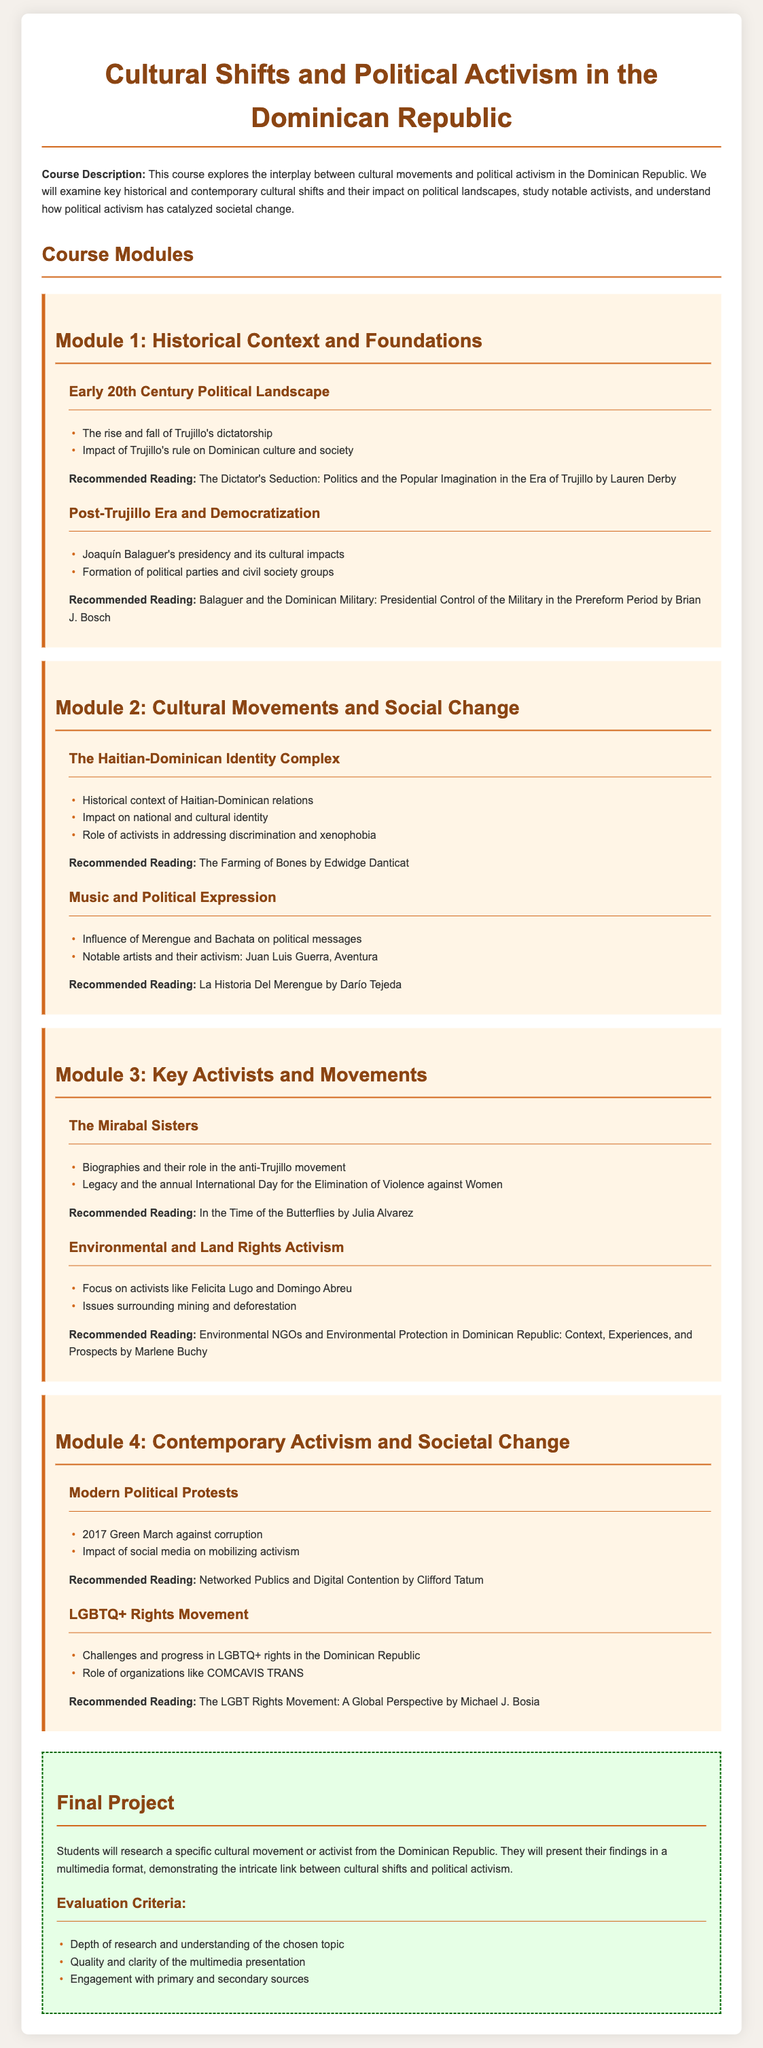What is the title of the course? The title of the course is prominently displayed at the top of the document.
Answer: Cultural Shifts and Political Activism in the Dominican Republic Who wrote "The Dictator's Seduction"? This is listed as a recommended reading in Module 1, specifically under the topic of the early 20th century political landscape.
Answer: Lauren Derby What cultural movement is associated with Juan Luis Guerra? This name appears under the topic discussing the influence of music on political messages.
Answer: Merengue Which module discusses LGBTQ+ rights? The module is explicitly named in the document, addressing contemporary societal issues in the Dominican Republic.
Answer: Module 4 What year did the Green March occur? The event is mentioned as a significant modern political protest in the syllabus.
Answer: 2017 Who were the Mirabal Sisters? This term is used in Module 3 and highlights their contribution to the anti-Trujillo movement.
Answer: Key activists What will students research for their final project? The document specifies that students will focus on a particular cultural movement or activist within the context of the course.
Answer: A specific cultural movement or activist What is the emphasis of Module 2? The title of the module provides insight into its primary focus, which combines culture and societal change.
Answer: Cultural Movements and Social Change Which artist is noted for activism in Bachata? The document notes this artist under the music and political expression section in Module 2.
Answer: Aventura 